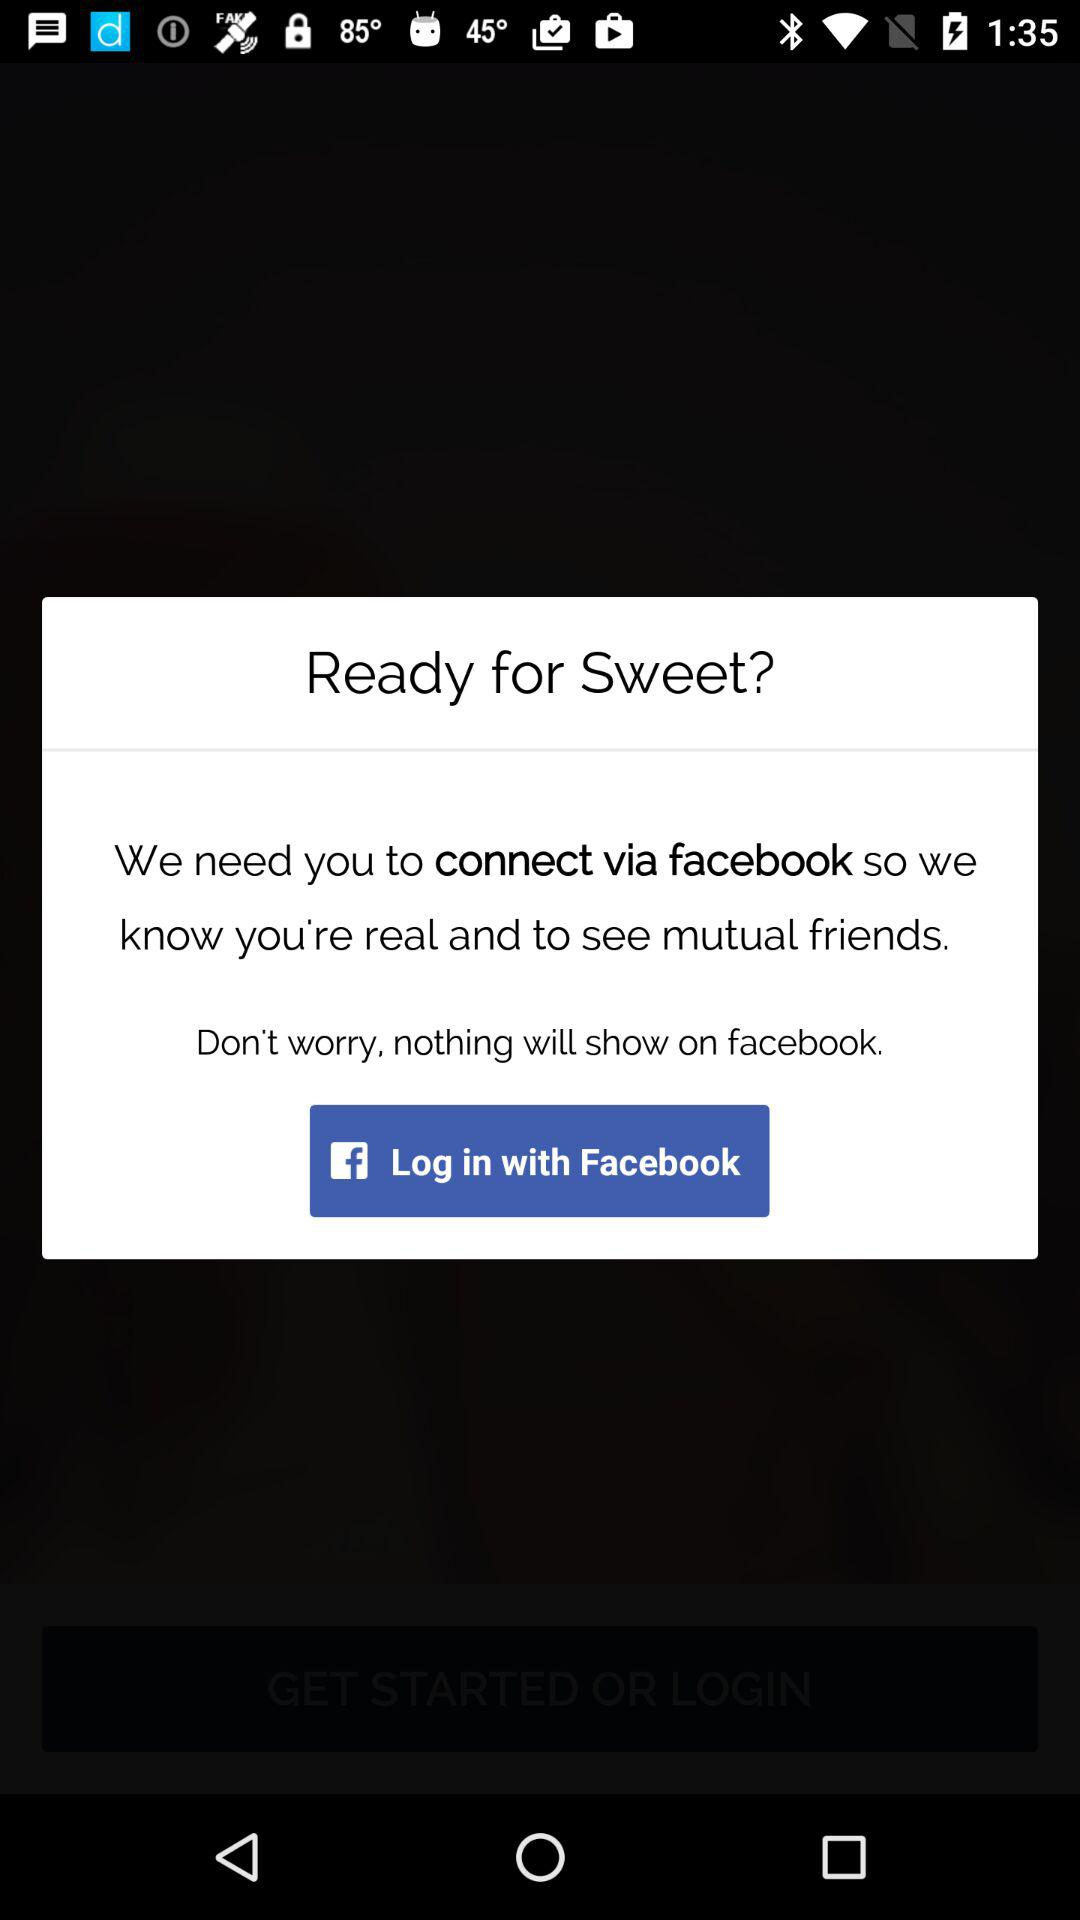How can we log in? You can log in through "Facebook". 